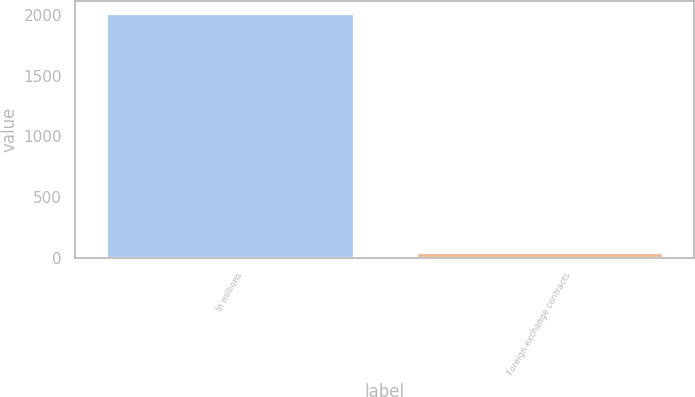<chart> <loc_0><loc_0><loc_500><loc_500><bar_chart><fcel>In millions<fcel>Foreign exchange contracts<nl><fcel>2014<fcel>54<nl></chart> 